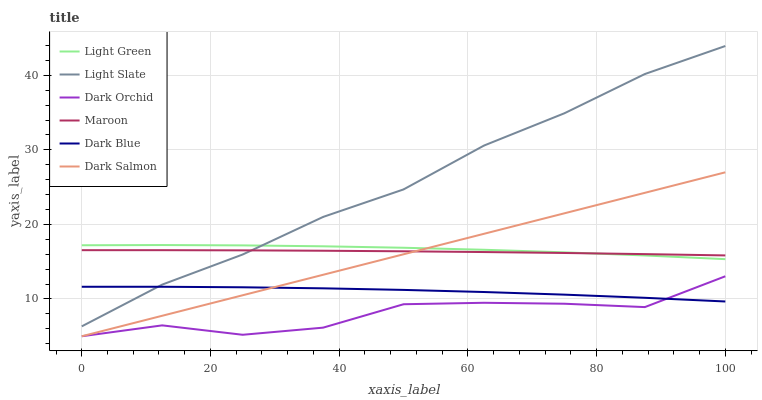Does Dark Orchid have the minimum area under the curve?
Answer yes or no. Yes. Does Light Slate have the maximum area under the curve?
Answer yes or no. Yes. Does Dark Salmon have the minimum area under the curve?
Answer yes or no. No. Does Dark Salmon have the maximum area under the curve?
Answer yes or no. No. Is Dark Salmon the smoothest?
Answer yes or no. Yes. Is Dark Orchid the roughest?
Answer yes or no. Yes. Is Maroon the smoothest?
Answer yes or no. No. Is Maroon the roughest?
Answer yes or no. No. Does Dark Salmon have the lowest value?
Answer yes or no. Yes. Does Maroon have the lowest value?
Answer yes or no. No. Does Light Slate have the highest value?
Answer yes or no. Yes. Does Dark Salmon have the highest value?
Answer yes or no. No. Is Dark Orchid less than Light Green?
Answer yes or no. Yes. Is Light Green greater than Dark Orchid?
Answer yes or no. Yes. Does Light Green intersect Maroon?
Answer yes or no. Yes. Is Light Green less than Maroon?
Answer yes or no. No. Is Light Green greater than Maroon?
Answer yes or no. No. Does Dark Orchid intersect Light Green?
Answer yes or no. No. 